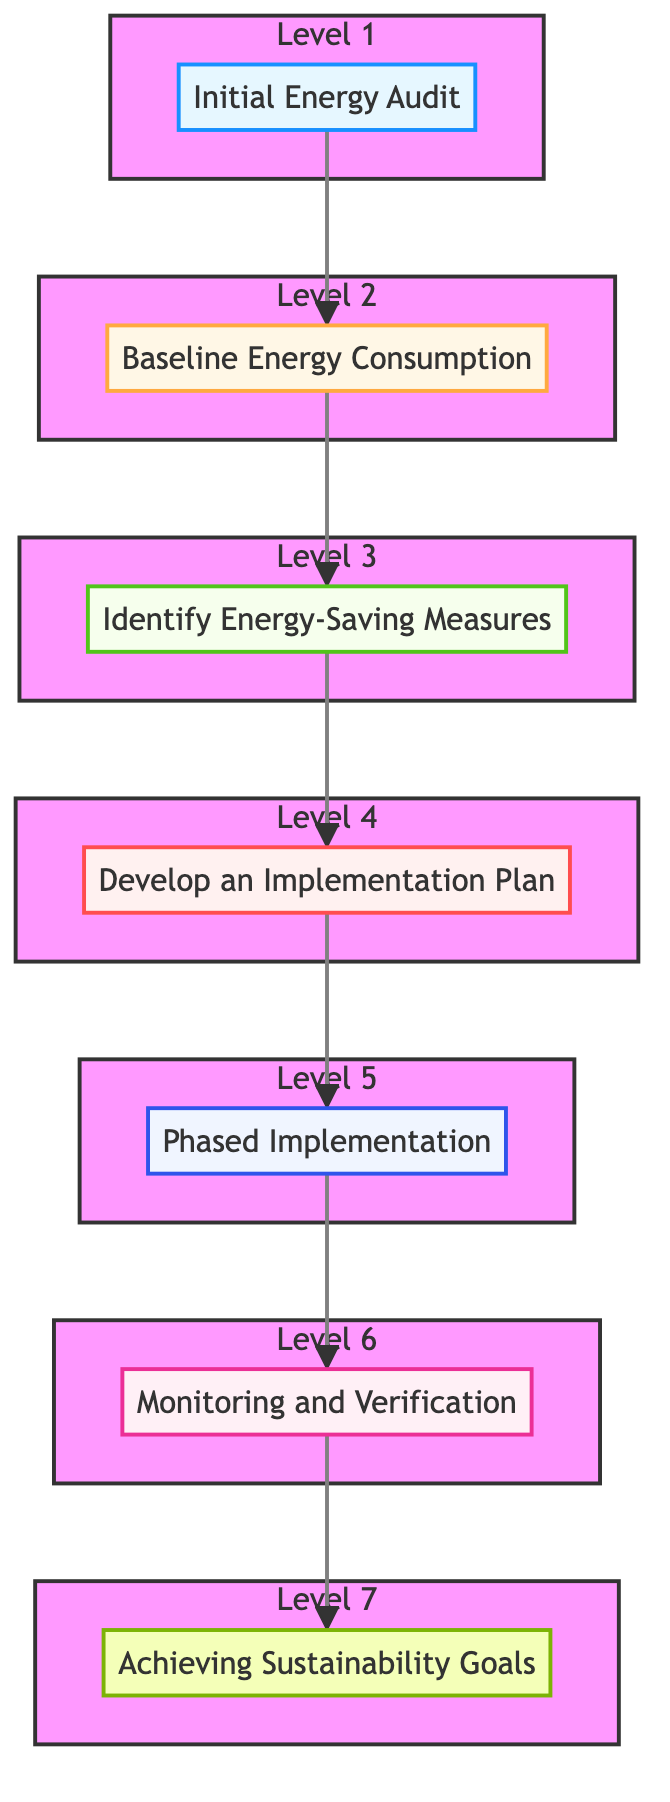What is the first step in the diagram? The diagram shows an upward flow beginning with "Initial Energy Audit" at the bottom, which is the first step in the process.
Answer: Initial Energy Audit How many total steps are there in the diagram? By counting all the steps listed from the initial energy audit to achieving sustainability goals, we find there are seven distinct steps.
Answer: 7 What step comes after "Baseline Energy Consumption"? The diagram indicates that "Identify Energy-Saving Measures" directly follows "Baseline Energy Consumption," showing the next phase in the energy efficiency process.
Answer: Identify Energy-Saving Measures Which step is labeled as the last in the process? The final step in the flow chart is "Achieving Sustainability Goals," which is at the top of the diagram, signifying the ultimate aim of the process.
Answer: Achieving Sustainability Goals What is the relationship between "Develop an Implementation Plan" and "Phased Implementation"? According to the flow, "Develop an Implementation Plan" precedes "Phased Implementation," indicating that the plan needs to be established before its execution starts.
Answer: Develop an Implementation Plan → Phased Implementation What type of entities are associated with the "Initial Energy Audit"? The diagram lists "Certified Energy Auditor" and "Energy Audit Report" as the real-world entities associated with the "Initial Energy Audit" step.
Answer: Certified Energy Auditor, Energy Audit Report Which two nodes are classified as level 3 in the diagram? The nodes at level 3 in the diagram are "Identify Energy-Saving Measures," which focuses on potential measures, and they are the sole representatives of this level, making them unique.
Answer: Identify Energy-Saving Measures How does the flow of the diagram demonstrate a progression? The flow chart visually progresses in a bottom-to-top manner, showing the sequence from initial audit to achieving sustainability goals, where each step logically builds upon the previous one to illustrate a clear pathway to energy efficiency implementation.
Answer: Progression from audit to sustainability goals What does the last step aim to achieve? The last step, "Achieving Sustainability Goals," aims to ensure that energy efficiency measures contribute to broader environmental sustainability objectives, such as reducing carbon footprint.
Answer: Sustainability objectives 